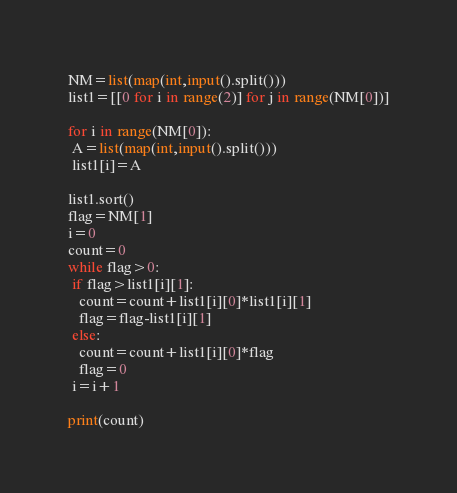Convert code to text. <code><loc_0><loc_0><loc_500><loc_500><_Python_>NM=list(map(int,input().split()))
list1=[[0 for i in range(2)] for j in range(NM[0])]

for i in range(NM[0]):
 A=list(map(int,input().split()))
 list1[i]=A

list1.sort()
flag=NM[1]
i=0
count=0
while flag>0:
 if flag>list1[i][1]:
   count=count+list1[i][0]*list1[i][1]
   flag=flag-list1[i][1]
 else:
   count=count+list1[i][0]*flag
   flag=0
 i=i+1

print(count)</code> 